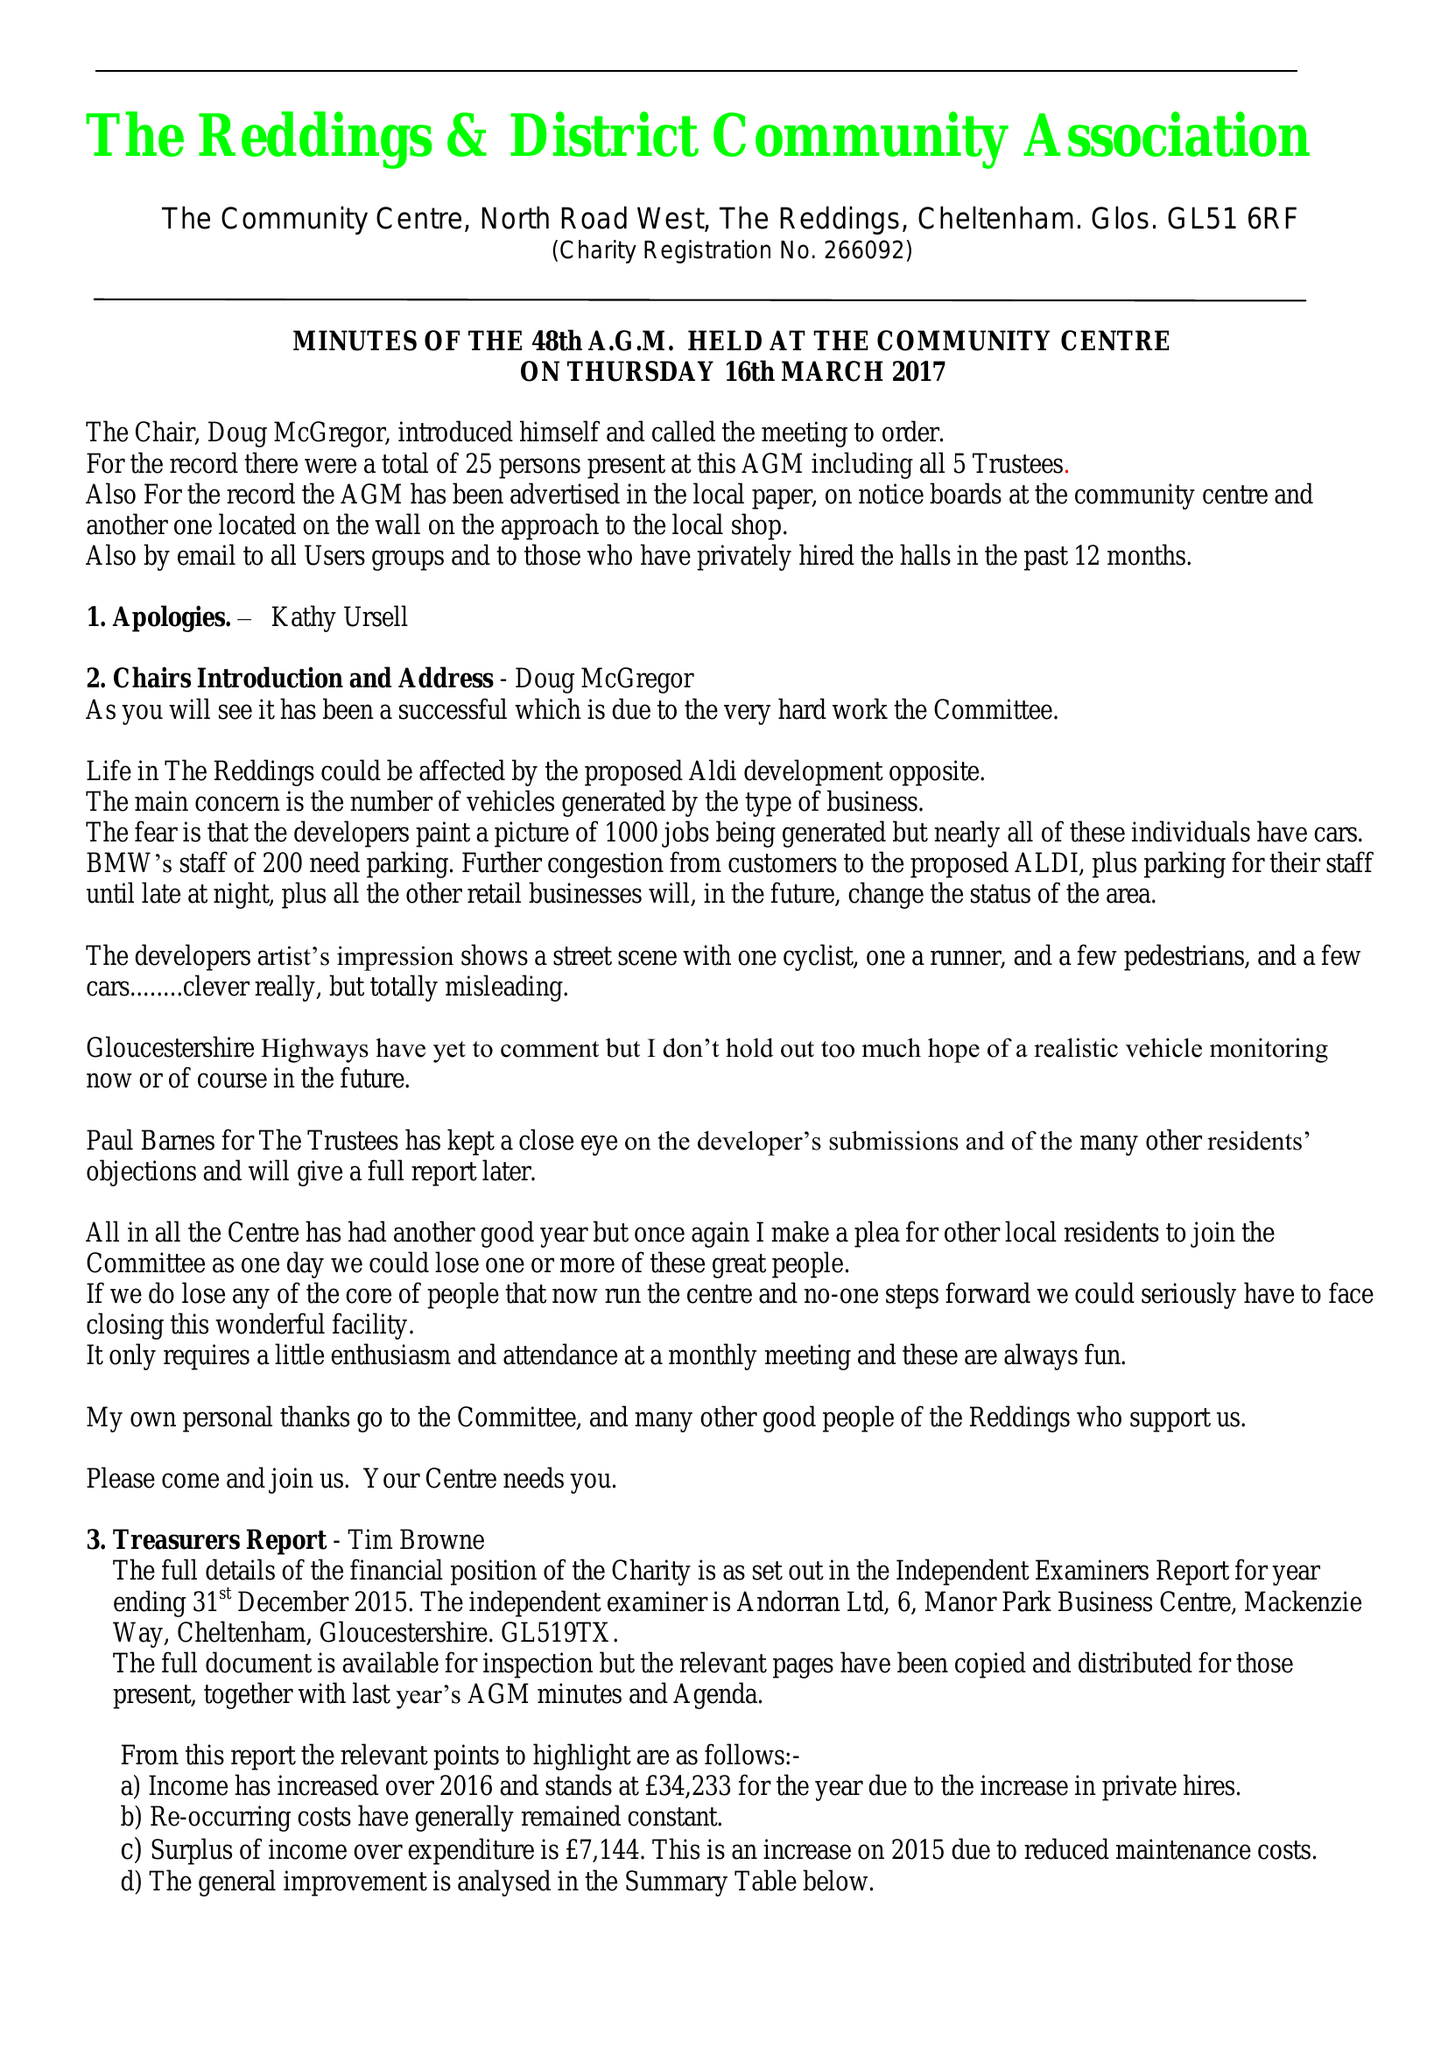What is the value for the charity_number?
Answer the question using a single word or phrase. 266092 